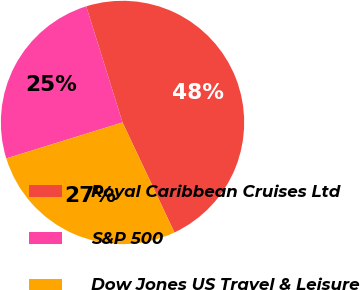<chart> <loc_0><loc_0><loc_500><loc_500><pie_chart><fcel>Royal Caribbean Cruises Ltd<fcel>S&P 500<fcel>Dow Jones US Travel & Leisure<nl><fcel>47.8%<fcel>24.96%<fcel>27.24%<nl></chart> 